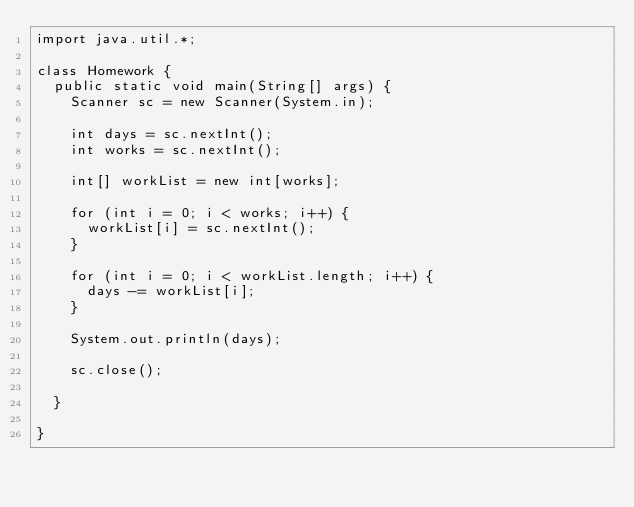Convert code to text. <code><loc_0><loc_0><loc_500><loc_500><_Java_>import java.util.*;

class Homework {
  public static void main(String[] args) {
    Scanner sc = new Scanner(System.in);

    int days = sc.nextInt();
    int works = sc.nextInt();

    int[] workList = new int[works];

    for (int i = 0; i < works; i++) {
      workList[i] = sc.nextInt();
    }

    for (int i = 0; i < workList.length; i++) {
      days -= workList[i];
    }

    System.out.println(days);

    sc.close();

  }

}</code> 